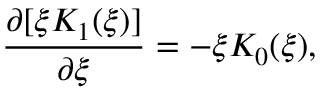Convert formula to latex. <formula><loc_0><loc_0><loc_500><loc_500>\frac { \partial [ \xi K _ { 1 } ( \xi ) ] } { \partial \xi } = - \xi K _ { 0 } ( \xi ) ,</formula> 